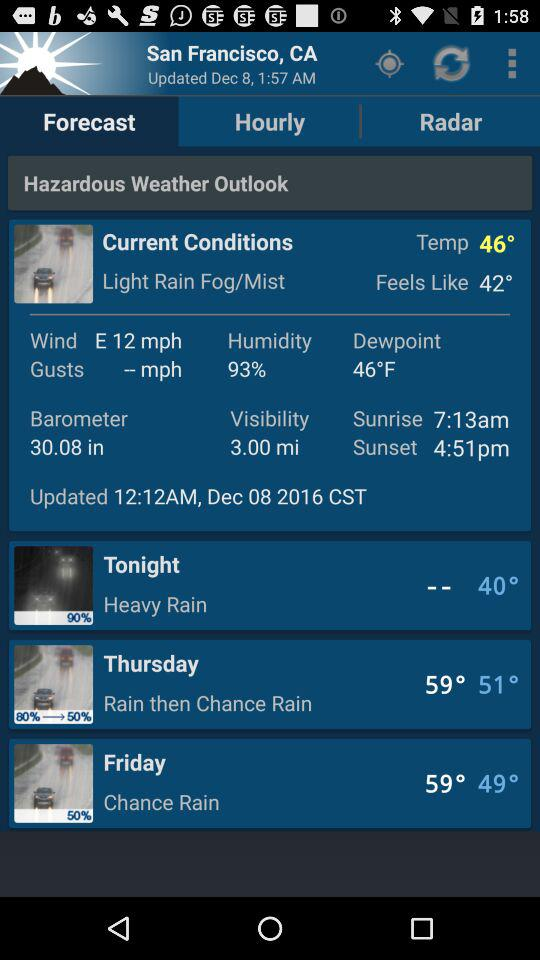What is the location? The location is San Francisco, CA. 